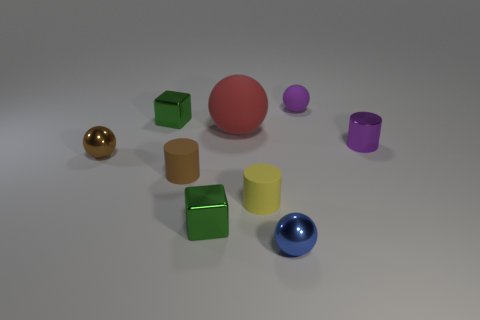Subtract all purple spheres. How many spheres are left? 3 Subtract all gray cubes. Subtract all cyan cylinders. How many cubes are left? 2 Subtract all gray spheres. How many brown cylinders are left? 1 Subtract all red rubber things. Subtract all brown spheres. How many objects are left? 7 Add 4 shiny objects. How many shiny objects are left? 9 Add 4 tiny brown objects. How many tiny brown objects exist? 6 Subtract all brown cylinders. How many cylinders are left? 2 Subtract 0 gray cylinders. How many objects are left? 9 Subtract all balls. How many objects are left? 5 Subtract 2 cylinders. How many cylinders are left? 1 